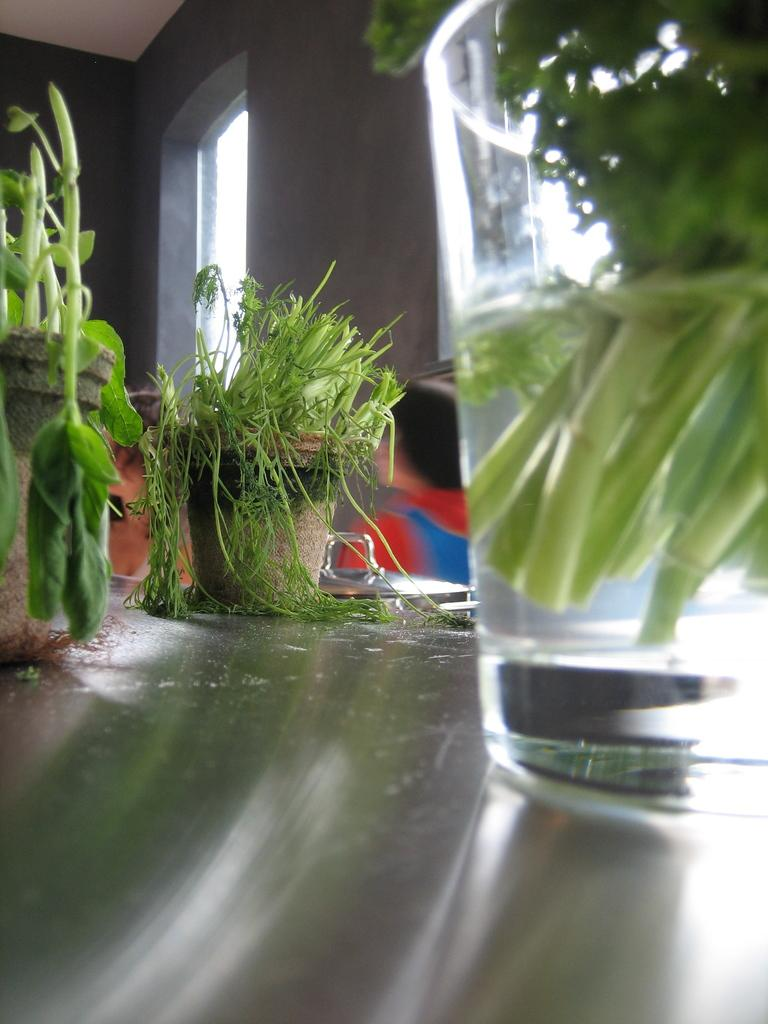What type of plants can be seen in the image? There are house plants in the image. Who or what is present in the image besides the plants? There are people in the image. What architectural feature is visible in the image? There are windows in the image. What type of container is visible in the image? There is a glass on a surface in the image. What is the opinion of the sleet on the dinner in the image? There is no mention of dinner or sleet in the image, so it is not possible to determine their opinions. 